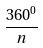<formula> <loc_0><loc_0><loc_500><loc_500>\frac { 3 6 0 ^ { 0 } } { n }</formula> 